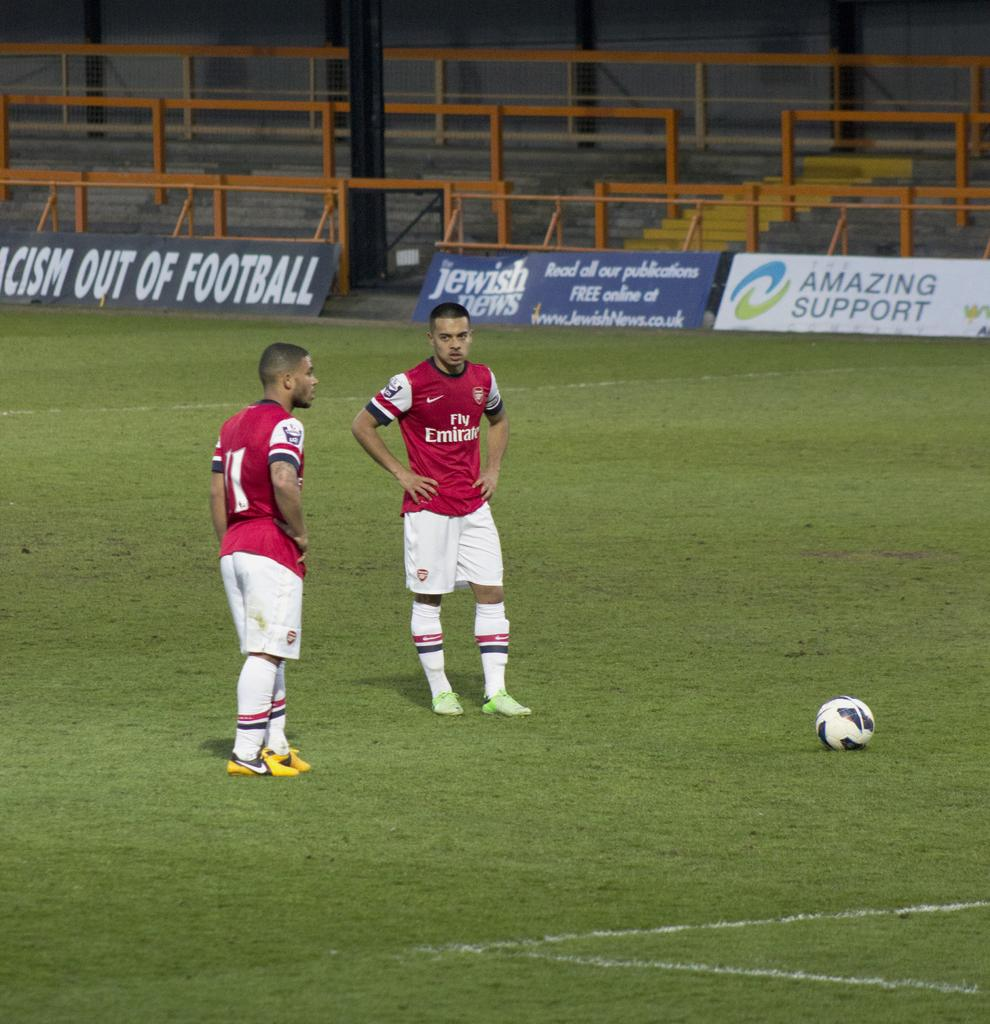<image>
Offer a succinct explanation of the picture presented. Soccer players wearing Fly Emirates jerseys are on a field. 